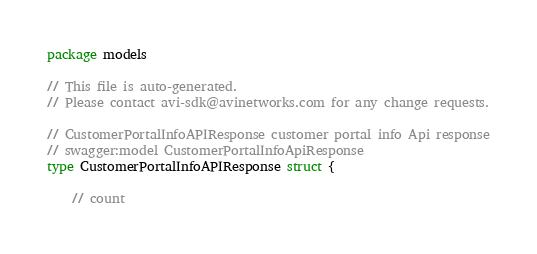<code> <loc_0><loc_0><loc_500><loc_500><_Go_>package models

// This file is auto-generated.
// Please contact avi-sdk@avinetworks.com for any change requests.

// CustomerPortalInfoAPIResponse customer portal info Api response
// swagger:model CustomerPortalInfoApiResponse
type CustomerPortalInfoAPIResponse struct {

	// count</code> 